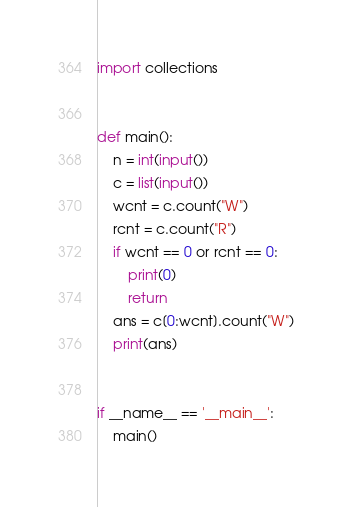Convert code to text. <code><loc_0><loc_0><loc_500><loc_500><_Python_>
import collections


def main():
    n = int(input())
    c = list(input())
    wcnt = c.count("W")
    rcnt = c.count("R")
    if wcnt == 0 or rcnt == 0:
        print(0)
        return
    ans = c[0:wcnt].count("W")
    print(ans)


if __name__ == '__main__':
    main()
</code> 